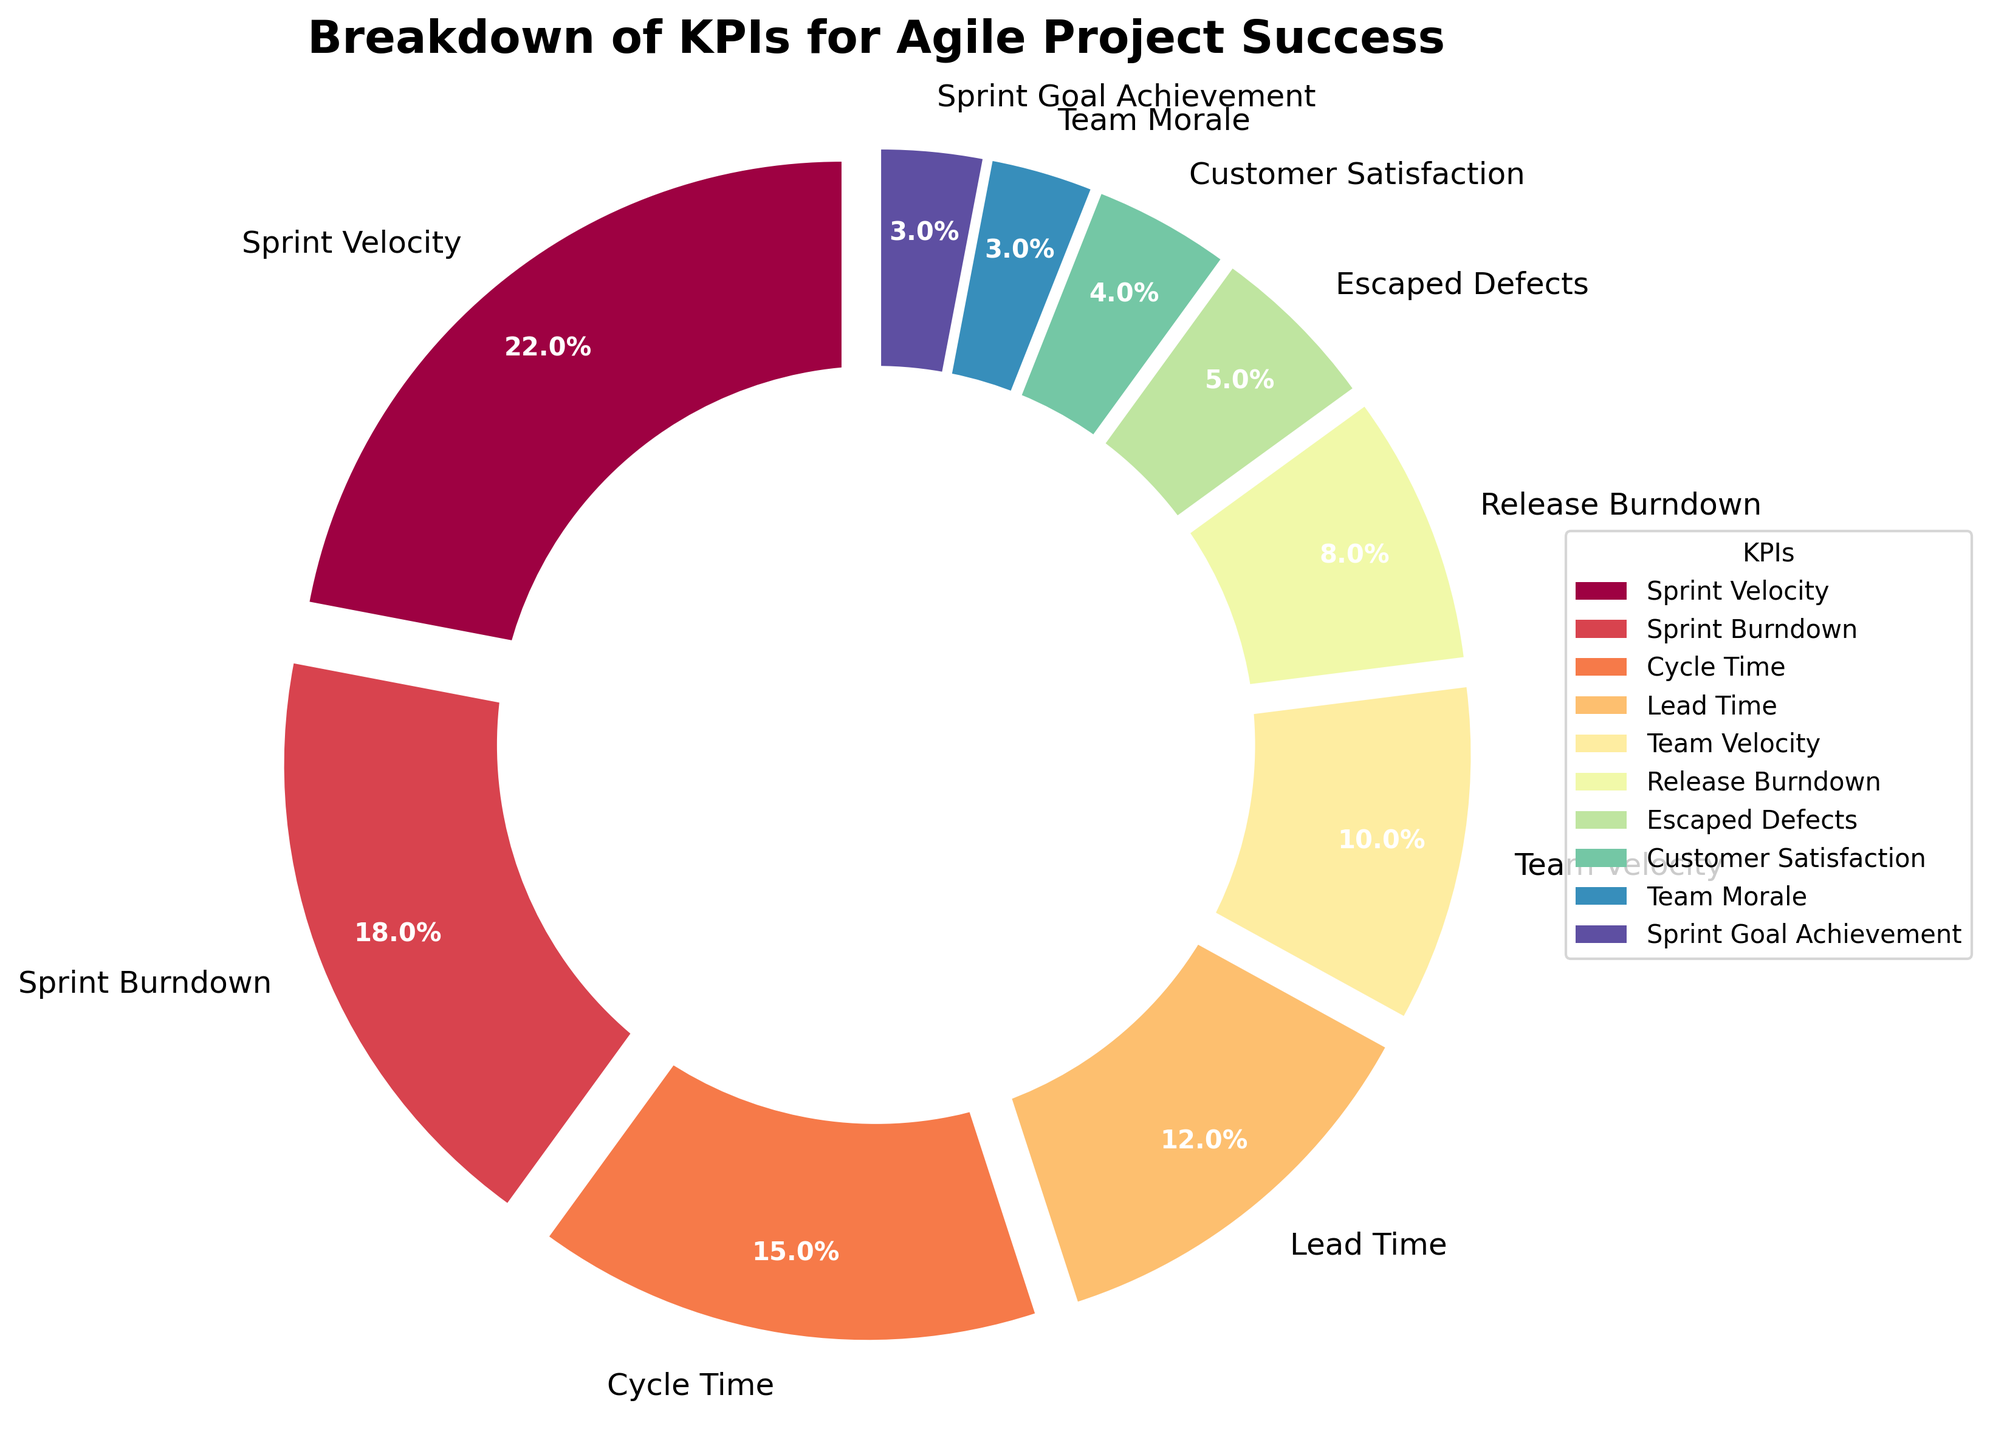Which KPI has the highest percentage? By visually inspecting the pie chart, you can identify the segment that covers the largest portion. The largest segment represents the KPI with the highest percentage. Based on the given data, 'Sprint Velocity' covers the largest area.
Answer: Sprint Velocity Which KPIs have a percentage less than 10%? Examine all the segments in the pie chart and look for the labels with less than 10% indicated in the corresponding sections. 'Release Burndown', 'Escaped Defects', 'Customer Satisfaction', 'Team Morale', and 'Sprint Goal Achievement' all fall under this criterion.
Answer: Release Burndown, Escaped Defects, Customer Satisfaction, Team Morale, Sprint Goal Achievement Compare the percentages of 'Sprint Burndown' and 'Cycle Time'. Which one is greater? Look at the pie chart sections labeled 'Sprint Burndown' and 'Cycle Time'. Comparing the indicated percentages, 'Sprint Burndown' has 18% and 'Cycle Time' has 15%. Therefore, 'Sprint Burndown' is greater.
Answer: Sprint Burndown What is the combined percentage of 'Sprint Velocity' and 'Team Velocity'? Locate the pie chart sections labeled 'Sprint Velocity' and 'Team Velocity' and observe their given percentages, 22% and 10% respectively. Adding these values together yields 32%.
Answer: 32% Which KPI is represented by the smallest segment in the pie chart? Visually inspect the pie chart to find the smallest segment. The smallest segment represents 'Team Morale' and 'Sprint Goal Achievement' both at 3%. Since these two share the same lowest value, the answer includes both.
Answer: Team Morale, Sprint Goal Achievement What percentage of the pie chart is occupied by 'Lead Time' and 'Customer Satisfaction' combined? Identify the sections labeled 'Lead Time' and 'Customer Satisfaction' in the pie chart. The given percentages are 12% for 'Lead Time' and 4% for 'Customer Satisfaction'. Adding these values together results in 16%.
Answer: 16% How does 'Cycle Time' compare to 'Lead Time' in terms of percentage? By locating both 'Cycle Time' and 'Lead Time' in the pie chart and comparing their respective percentages, 'Cycle Time' has 15% while 'Lead Time' has 12%. Therefore, 'Cycle Time' is greater than 'Lead Time'.
Answer: Cycle Time Find the total percentage of all KPIs that have a percentage higher than 'Escaped Defects'. First, identify the percentage of 'Escaped Defects' which is 5%. Then sum the percentages of all KPIs higher than 5%: 'Sprint Velocity' (22%), 'Sprint Burndown' (18%), 'Cycle Time' (15%), 'Lead Time' (12%), 'Team Velocity' (10%), 'Release Burndown' (8%). Adding these gives 85%.
Answer: 85% How many KPIs have a percentage larger than 15%? Identify all the KPIs and their corresponding percentages. Then count the KPIs with percentages larger than 15%: 'Sprint Velocity' (22%), 'Sprint Burndown' (18%), and 'Cycle Time' (15%). Since 'Cycle Time' is exactly 15% and does not meet the "larger than" criterion, the count is just for the first two.
Answer: 2 